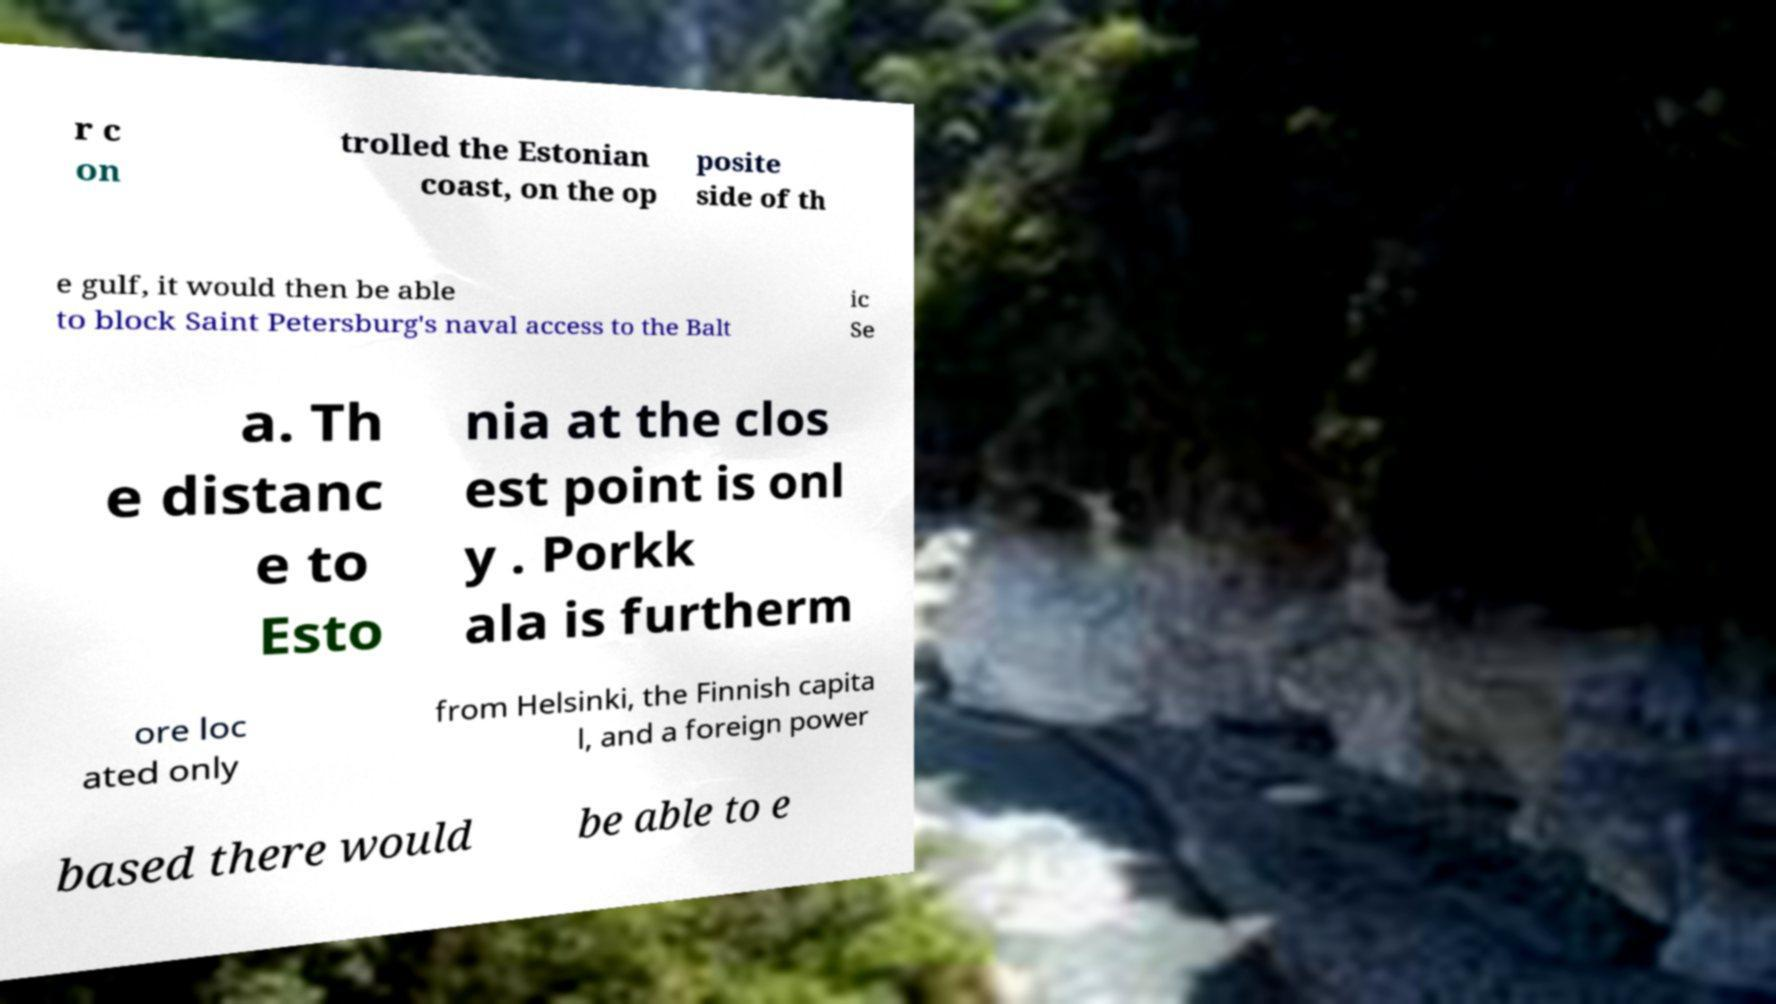Could you extract and type out the text from this image? r c on trolled the Estonian coast, on the op posite side of th e gulf, it would then be able to block Saint Petersburg's naval access to the Balt ic Se a. Th e distanc e to Esto nia at the clos est point is onl y . Porkk ala is furtherm ore loc ated only from Helsinki, the Finnish capita l, and a foreign power based there would be able to e 